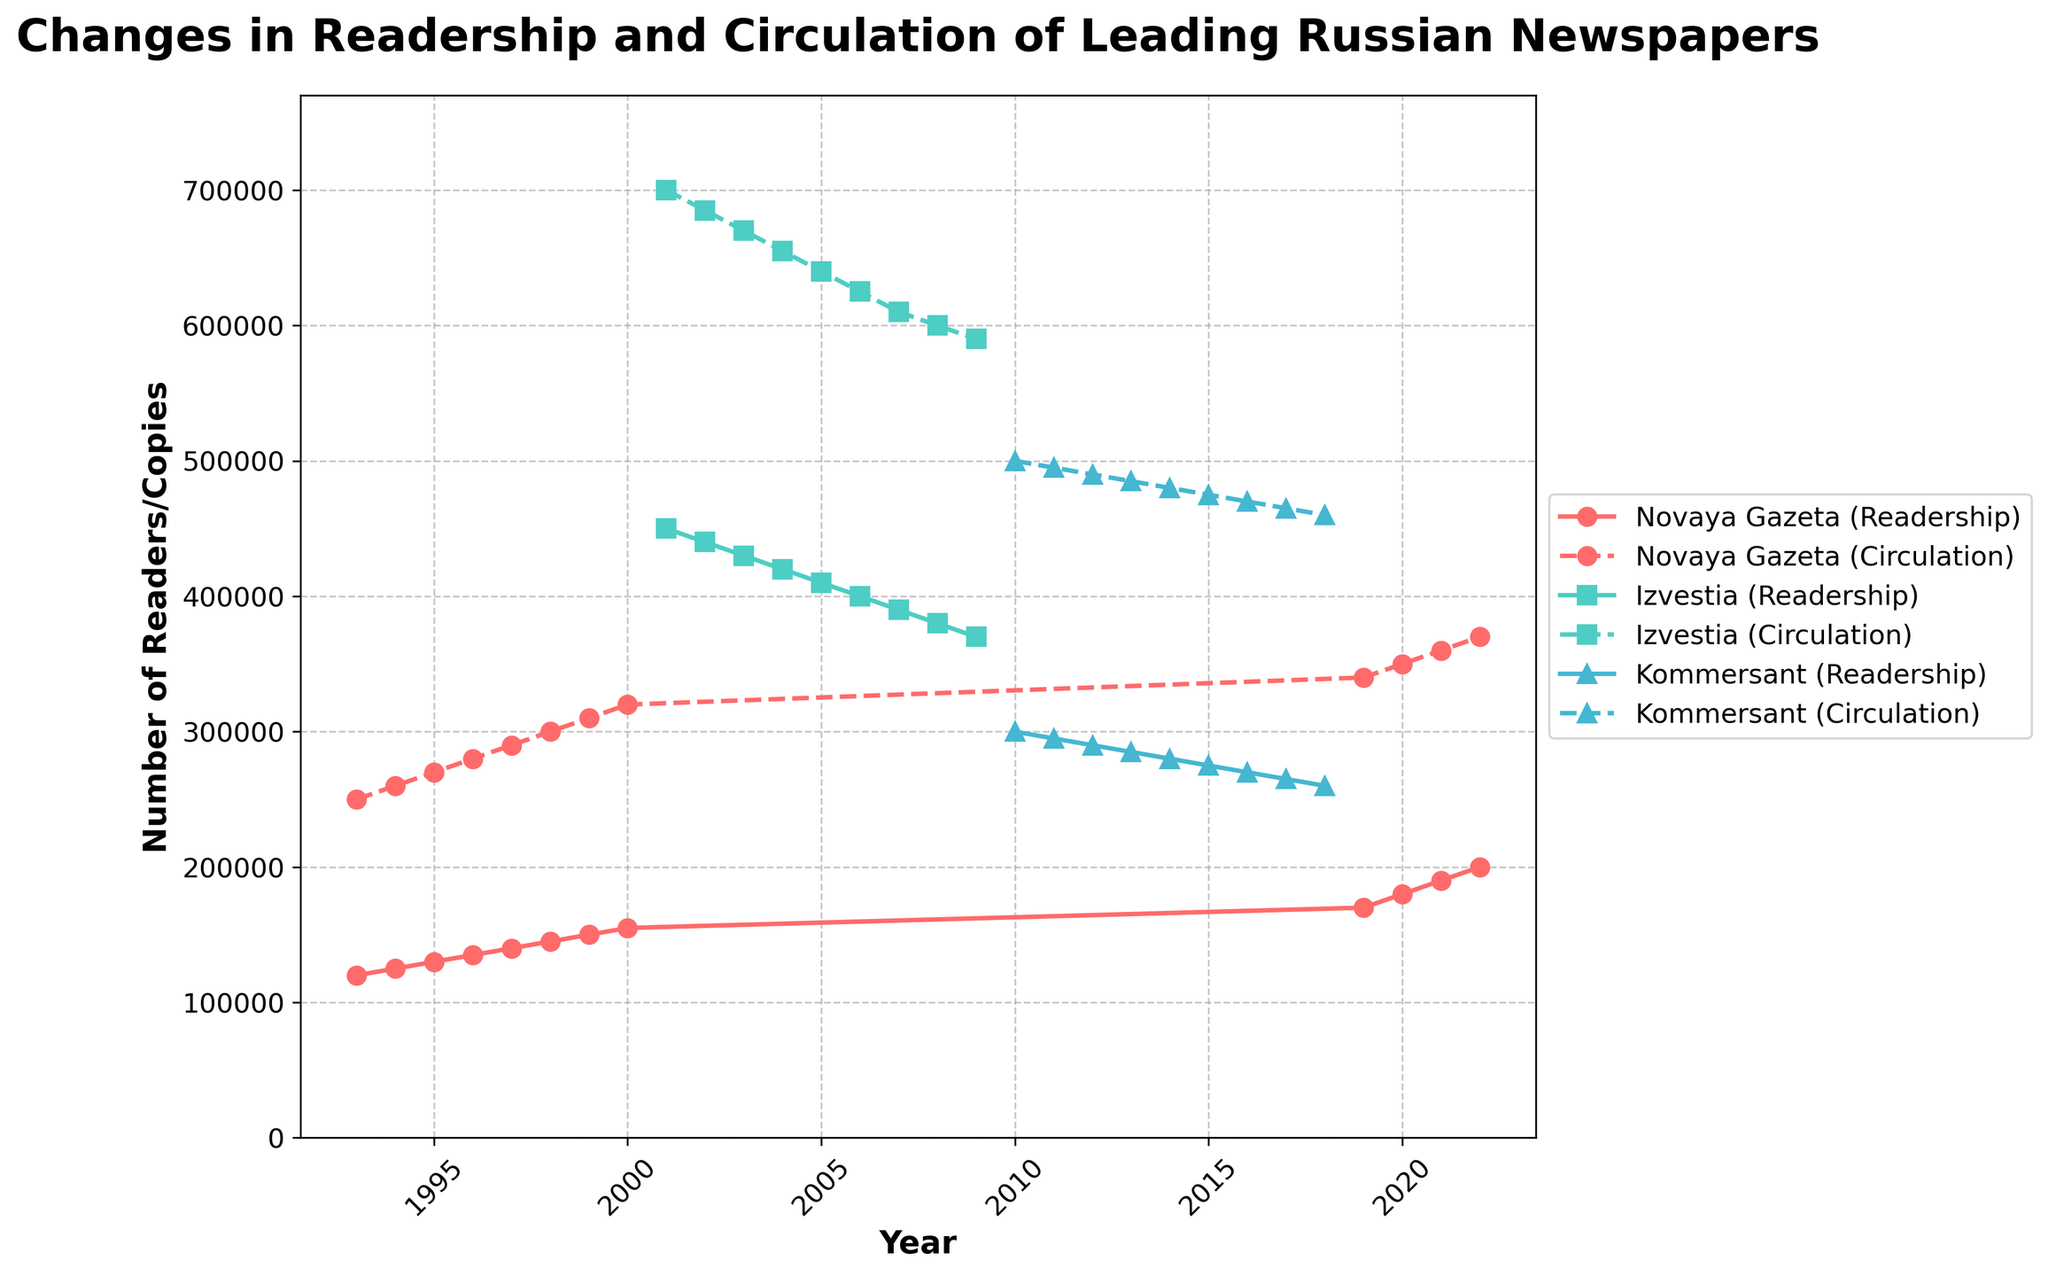What's the title of the figure? The title is displayed at the top of the figure in a larger, bold font, and it summarizes the content of the plot.
Answer: Changes in Readership and Circulation of Leading Russian Newspapers What is the range of years shown on the x-axis? The x-axis represents time and the range can be identified starting from the earliest year to the latest year on the axis labels.
Answer: 1993 to 2022 Which newspaper has the highest peak readership? By examining the top-most points of the lines labeled with (Readership), we can find the maximum value.
Answer: Izvestia How does the readership of Novaya Gazeta in 2022 compare to its readership in 1993? Find the points labeled Novaya Gazeta (Readership) at 1993 and 2022, then compare the values.
Answer: 200,000 is higher than 120,000 What are the main colors used to represent the different newspapers? The colors can be identified by looking at the lines and their corresponding labels in the legend.
Answer: Red, turquoise, blue What pattern do you observe in the circulation numbers for Izvestia over the years? Look at the line labeled Izvestia (Circulation) and observe its trend over the years.
Answer: Gradually decreasing Calculate the average readership of Kommersant from 2010 to 2018. Locate Kommersant (Readership) from 2010 to 2018, sum the values, and divide by the number of years.
Answer: (300,000 + 295,000 + 290,000 + 285,000 + 280,000 + 275,000 + 270,000 + 265,000 + 260,000) / 9 = 278,889 Between which years did Novaya Gazeta see the most significant increase in readership? Find the years with the steepest slope on the Novaya Gazeta (Readership) line.
Answer: 2019 to 2020 Which newspaper shows a consistent trend in both readership and circulation, and what is the trend? Look for a newspaper where both (Readership) and (Circulation) lines exhibit a clear, consistent trend over the years.
Answer: Izvestia, gradually decreasing in both How did the circulation of Kommersant change from 2010 to 2018? Locate Kommersant (Circulation) at 2010 and 2018, then note the difference.
Answer: 500,000 to 460,000, decrease by 40,000 